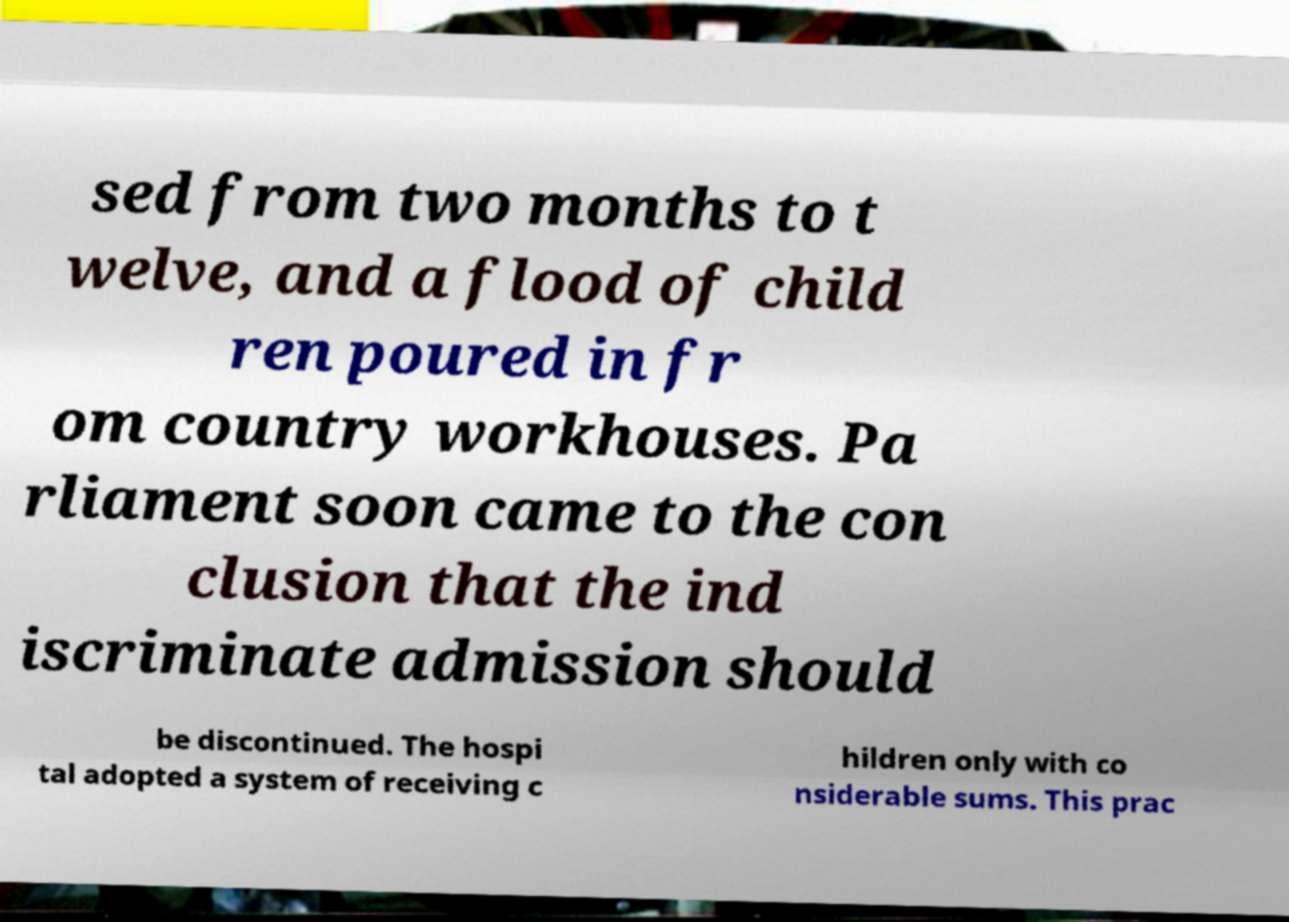Could you extract and type out the text from this image? sed from two months to t welve, and a flood of child ren poured in fr om country workhouses. Pa rliament soon came to the con clusion that the ind iscriminate admission should be discontinued. The hospi tal adopted a system of receiving c hildren only with co nsiderable sums. This prac 